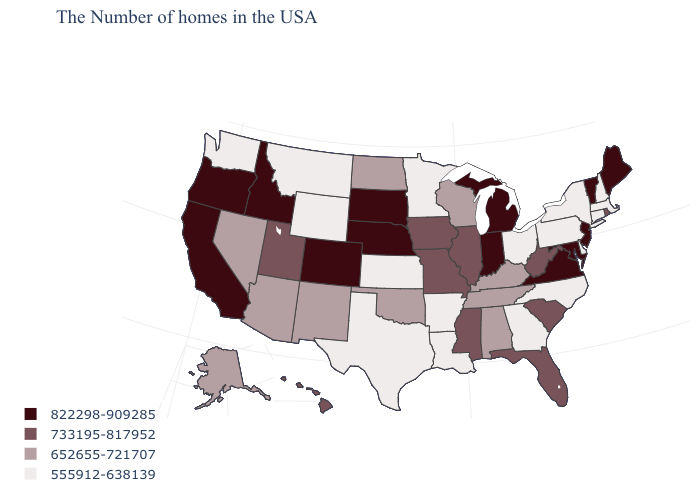What is the value of Washington?
Quick response, please. 555912-638139. What is the highest value in the USA?
Write a very short answer. 822298-909285. Name the states that have a value in the range 652655-721707?
Short answer required. Kentucky, Alabama, Tennessee, Wisconsin, Oklahoma, North Dakota, New Mexico, Arizona, Nevada, Alaska. What is the value of Oregon?
Quick response, please. 822298-909285. Name the states that have a value in the range 555912-638139?
Answer briefly. Massachusetts, New Hampshire, Connecticut, New York, Delaware, Pennsylvania, North Carolina, Ohio, Georgia, Louisiana, Arkansas, Minnesota, Kansas, Texas, Wyoming, Montana, Washington. Does Minnesota have the highest value in the MidWest?
Write a very short answer. No. Among the states that border Florida , does Georgia have the lowest value?
Be succinct. Yes. Among the states that border Michigan , which have the highest value?
Short answer required. Indiana. How many symbols are there in the legend?
Quick response, please. 4. Among the states that border Mississippi , does Alabama have the highest value?
Answer briefly. Yes. What is the value of New Hampshire?
Keep it brief. 555912-638139. Name the states that have a value in the range 822298-909285?
Answer briefly. Maine, Vermont, New Jersey, Maryland, Virginia, Michigan, Indiana, Nebraska, South Dakota, Colorado, Idaho, California, Oregon. What is the value of Idaho?
Write a very short answer. 822298-909285. What is the value of South Dakota?
Short answer required. 822298-909285. What is the value of Louisiana?
Concise answer only. 555912-638139. 